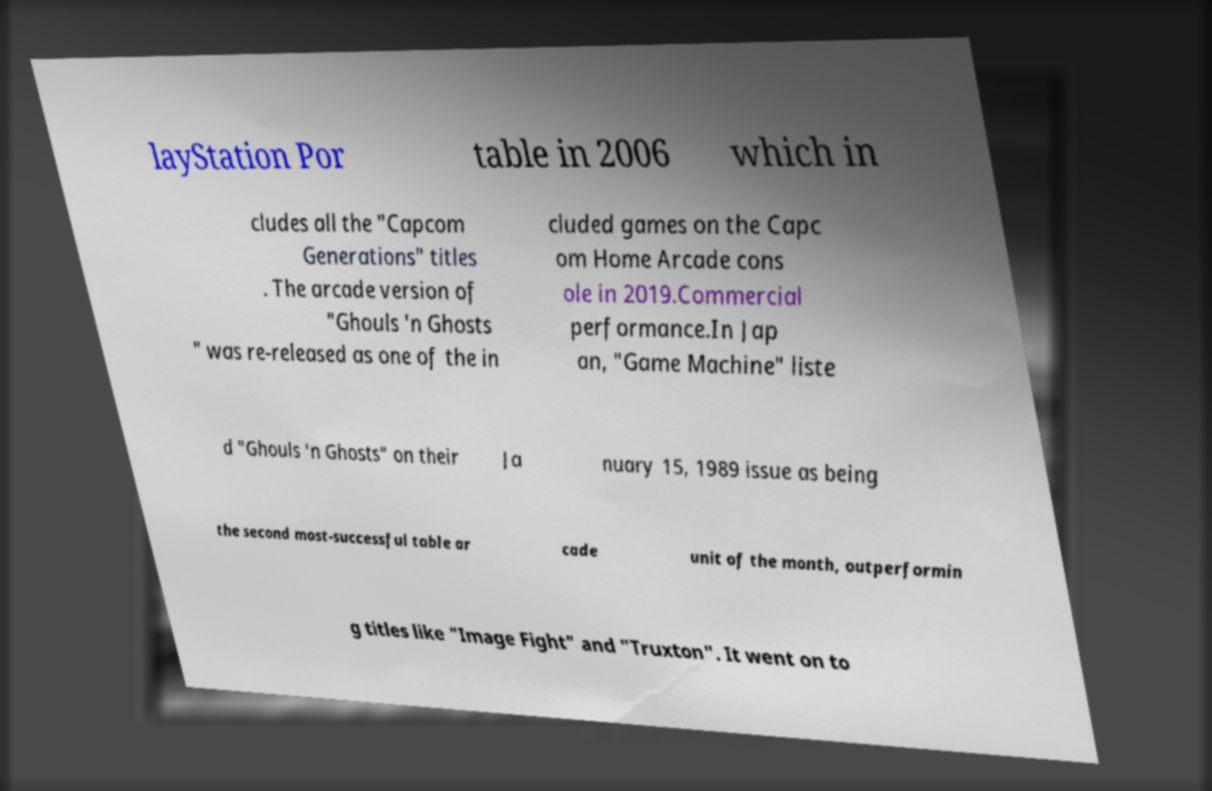Please read and relay the text visible in this image. What does it say? layStation Por table in 2006 which in cludes all the "Capcom Generations" titles . The arcade version of "Ghouls 'n Ghosts " was re-released as one of the in cluded games on the Capc om Home Arcade cons ole in 2019.Commercial performance.In Jap an, "Game Machine" liste d "Ghouls 'n Ghosts" on their Ja nuary 15, 1989 issue as being the second most-successful table ar cade unit of the month, outperformin g titles like "Image Fight" and "Truxton". It went on to 